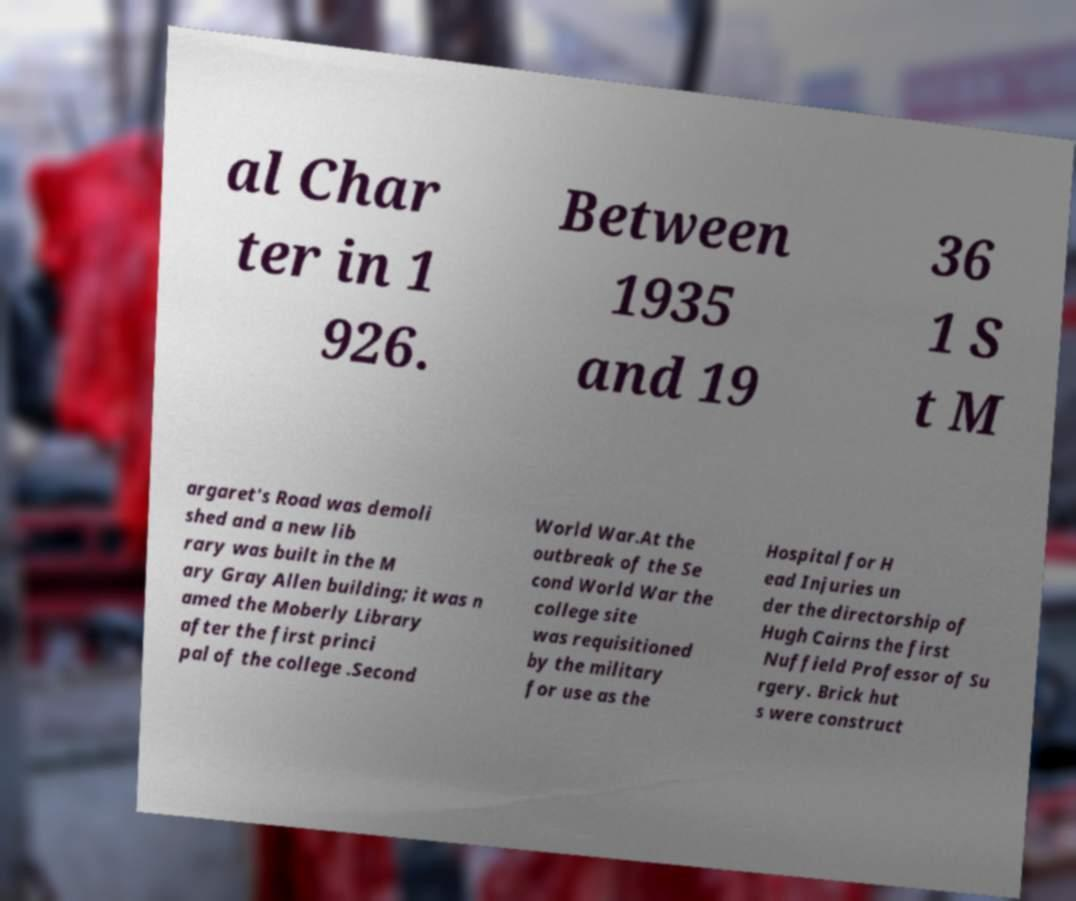Can you read and provide the text displayed in the image?This photo seems to have some interesting text. Can you extract and type it out for me? al Char ter in 1 926. Between 1935 and 19 36 1 S t M argaret's Road was demoli shed and a new lib rary was built in the M ary Gray Allen building; it was n amed the Moberly Library after the first princi pal of the college .Second World War.At the outbreak of the Se cond World War the college site was requisitioned by the military for use as the Hospital for H ead Injuries un der the directorship of Hugh Cairns the first Nuffield Professor of Su rgery. Brick hut s were construct 